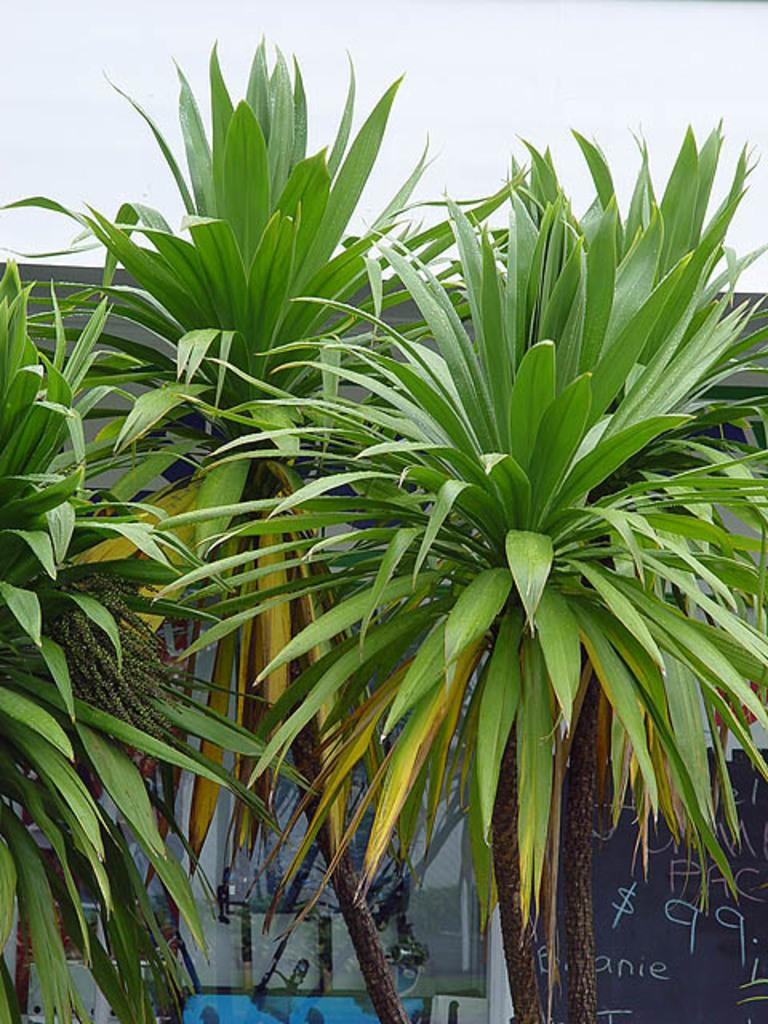What type of vegetation can be seen in the image? There are trees in the image. What is written or displayed on the board in the image? There is a board with text in the image. What material is transparent and visible in the image? There is glass visible in the image. How many objects can be identified in the image? There are a few objects in the image. What color is one of the objects in the image? There is a blue colored object in the image. What part of the natural environment is visible in the image? The sky is visible in the image. How many beds are visible in the image? There are no beds present in the image. What type of nut is being cracked by the person in the image? There is no person or nut present in the image. 